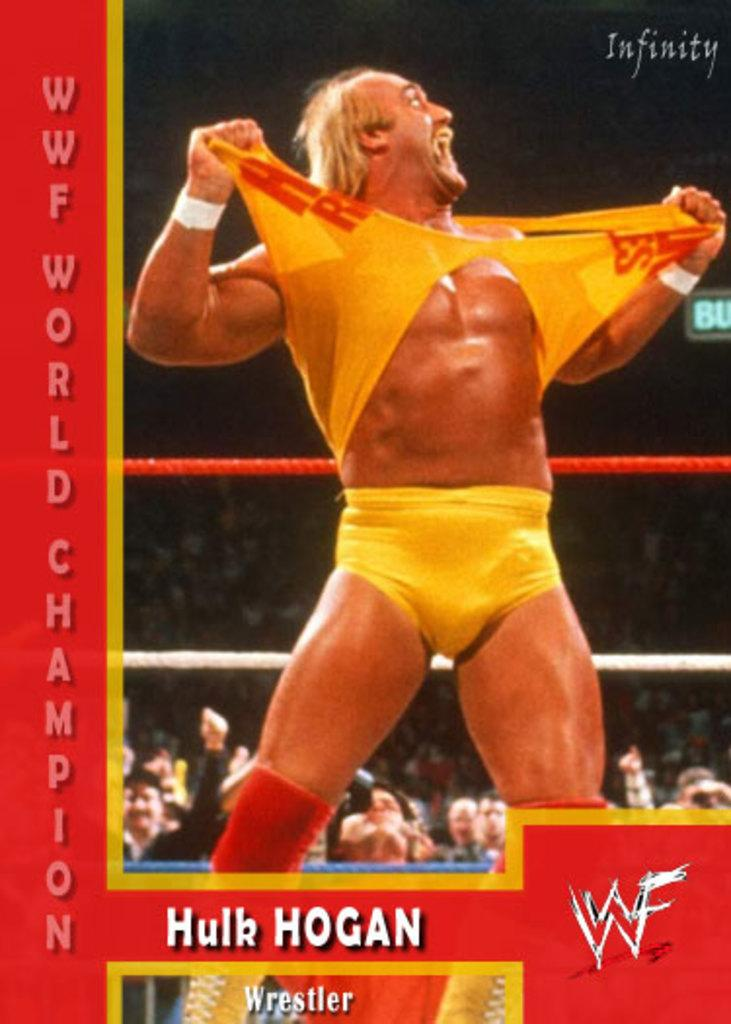<image>
Relay a brief, clear account of the picture shown. Hulk Hogan the famous wrestler is ripping his top off in the ring. 